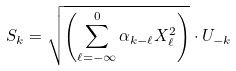Convert formula to latex. <formula><loc_0><loc_0><loc_500><loc_500>S _ { k } = \sqrt { \left ( \sum _ { \ell = - \infty } ^ { 0 } \alpha _ { k - \ell } X _ { \ell } ^ { 2 } \right ) } \cdot U _ { - k }</formula> 